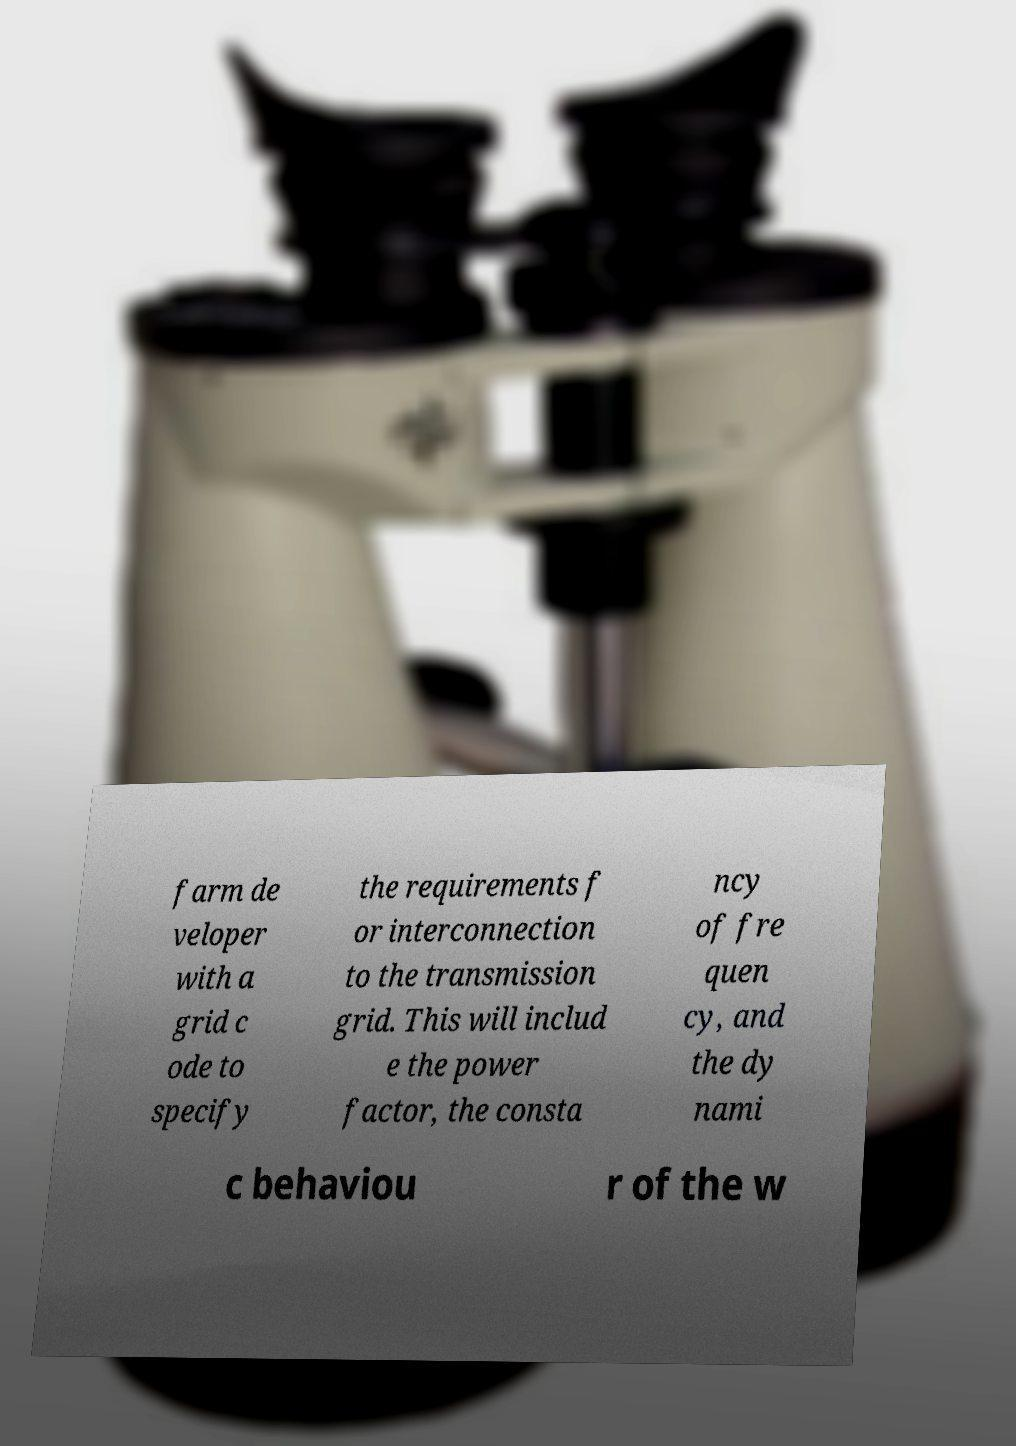What messages or text are displayed in this image? I need them in a readable, typed format. farm de veloper with a grid c ode to specify the requirements f or interconnection to the transmission grid. This will includ e the power factor, the consta ncy of fre quen cy, and the dy nami c behaviou r of the w 